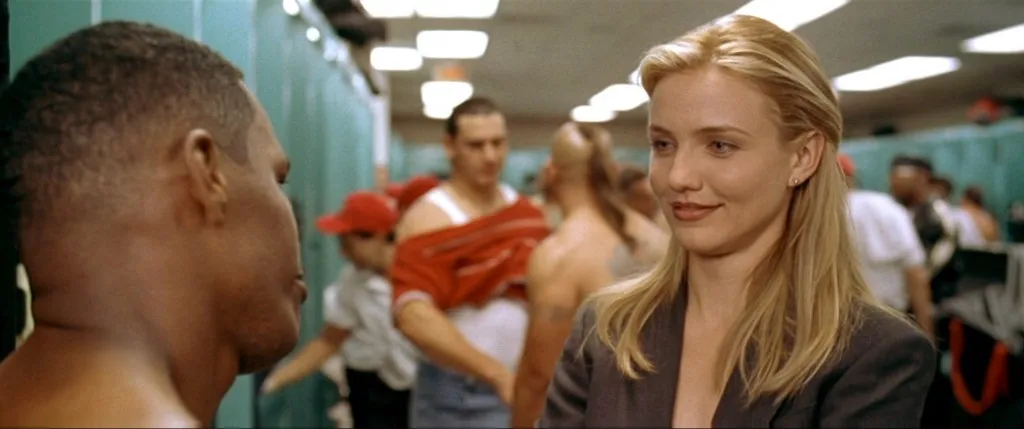What do you think these characters' hobbies are? The woman, given her professional demeanor, might enjoy sophisticated and relaxing hobbies like reading classic literature, attending theater performances, or engaging in high-level networking events. The man, on the other hand, might relish physical activities like rock climbing or martial arts to channel his energy and unwind after a busy day. They may even share a mutual love of intellectual pursuits such as attending seminars or participating in book clubs, fostering both knowledge and camaraderie outside their professional lives. 